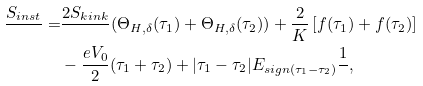Convert formula to latex. <formula><loc_0><loc_0><loc_500><loc_500>\frac { S _ { i n s t } } { } = & \frac { 2 S _ { k i n k } } { } ( \Theta _ { H , \delta } ( \tau _ { 1 } ) + \Theta _ { H , \delta } ( \tau _ { 2 } ) ) + \frac { 2 } { K } \left [ f ( \tau _ { 1 } ) + f ( \tau _ { 2 } ) \right ] \\ & - \frac { e V _ { 0 } } { 2 } ( \tau _ { 1 } + \tau _ { 2 } ) + | \tau _ { 1 } - \tau _ { 2 } | { E _ { s i g n ( \tau _ { 1 } - \tau _ { 2 } ) } } \frac { 1 } { } ,</formula> 